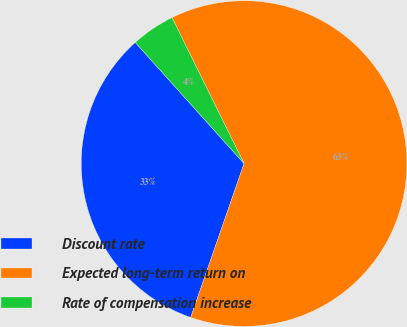<chart> <loc_0><loc_0><loc_500><loc_500><pie_chart><fcel>Discount rate<fcel>Expected long-term return on<fcel>Rate of compensation increase<nl><fcel>33.04%<fcel>62.61%<fcel>4.35%<nl></chart> 